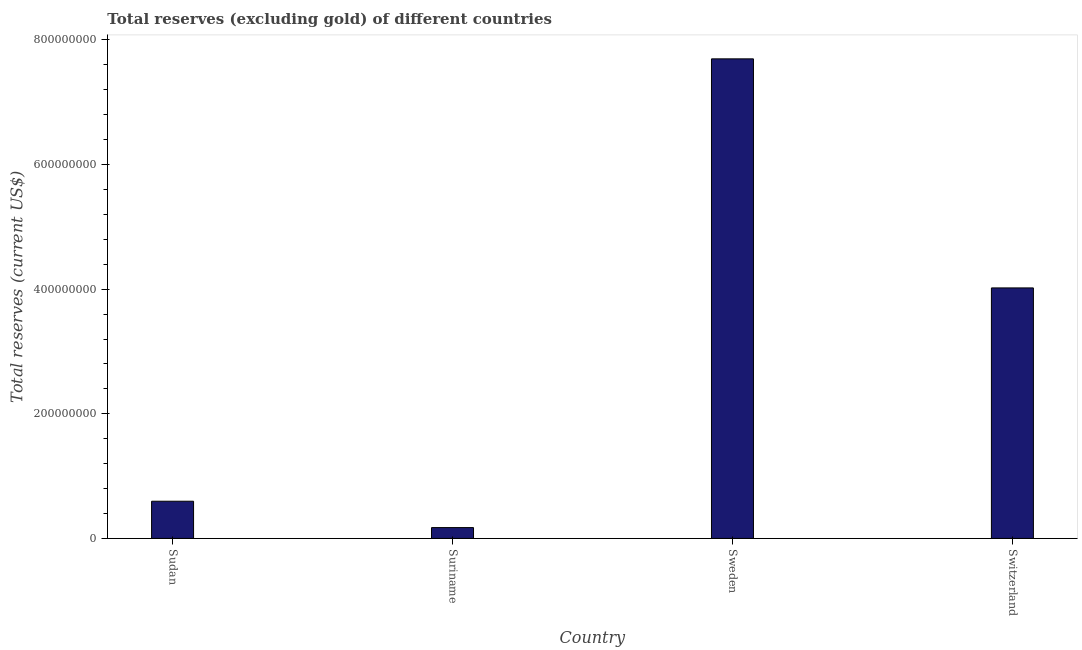Does the graph contain any zero values?
Offer a terse response. No. What is the title of the graph?
Your answer should be very brief. Total reserves (excluding gold) of different countries. What is the label or title of the X-axis?
Your response must be concise. Country. What is the label or title of the Y-axis?
Make the answer very short. Total reserves (current US$). What is the total reserves (excluding gold) in Switzerland?
Ensure brevity in your answer.  4.02e+08. Across all countries, what is the maximum total reserves (excluding gold)?
Ensure brevity in your answer.  7.70e+08. Across all countries, what is the minimum total reserves (excluding gold)?
Offer a terse response. 1.74e+07. In which country was the total reserves (excluding gold) minimum?
Ensure brevity in your answer.  Suriname. What is the sum of the total reserves (excluding gold)?
Your response must be concise. 1.25e+09. What is the difference between the total reserves (excluding gold) in Sudan and Suriname?
Make the answer very short. 4.23e+07. What is the average total reserves (excluding gold) per country?
Offer a terse response. 3.12e+08. What is the median total reserves (excluding gold)?
Provide a short and direct response. 2.31e+08. In how many countries, is the total reserves (excluding gold) greater than 760000000 US$?
Offer a terse response. 1. What is the ratio of the total reserves (excluding gold) in Sudan to that in Sweden?
Keep it short and to the point. 0.08. Is the difference between the total reserves (excluding gold) in Suriname and Sweden greater than the difference between any two countries?
Give a very brief answer. Yes. What is the difference between the highest and the second highest total reserves (excluding gold)?
Give a very brief answer. 3.68e+08. Is the sum of the total reserves (excluding gold) in Sudan and Switzerland greater than the maximum total reserves (excluding gold) across all countries?
Give a very brief answer. No. What is the difference between the highest and the lowest total reserves (excluding gold)?
Make the answer very short. 7.52e+08. In how many countries, is the total reserves (excluding gold) greater than the average total reserves (excluding gold) taken over all countries?
Ensure brevity in your answer.  2. How many bars are there?
Make the answer very short. 4. How many countries are there in the graph?
Provide a short and direct response. 4. What is the difference between two consecutive major ticks on the Y-axis?
Your answer should be very brief. 2.00e+08. What is the Total reserves (current US$) in Sudan?
Give a very brief answer. 5.97e+07. What is the Total reserves (current US$) of Suriname?
Offer a terse response. 1.74e+07. What is the Total reserves (current US$) in Sweden?
Offer a terse response. 7.70e+08. What is the Total reserves (current US$) in Switzerland?
Keep it short and to the point. 4.02e+08. What is the difference between the Total reserves (current US$) in Sudan and Suriname?
Make the answer very short. 4.23e+07. What is the difference between the Total reserves (current US$) in Sudan and Sweden?
Your answer should be compact. -7.10e+08. What is the difference between the Total reserves (current US$) in Sudan and Switzerland?
Give a very brief answer. -3.42e+08. What is the difference between the Total reserves (current US$) in Suriname and Sweden?
Offer a terse response. -7.52e+08. What is the difference between the Total reserves (current US$) in Suriname and Switzerland?
Give a very brief answer. -3.85e+08. What is the difference between the Total reserves (current US$) in Sweden and Switzerland?
Make the answer very short. 3.68e+08. What is the ratio of the Total reserves (current US$) in Sudan to that in Suriname?
Your answer should be compact. 3.43. What is the ratio of the Total reserves (current US$) in Sudan to that in Sweden?
Give a very brief answer. 0.08. What is the ratio of the Total reserves (current US$) in Sudan to that in Switzerland?
Make the answer very short. 0.15. What is the ratio of the Total reserves (current US$) in Suriname to that in Sweden?
Give a very brief answer. 0.02. What is the ratio of the Total reserves (current US$) in Suriname to that in Switzerland?
Keep it short and to the point. 0.04. What is the ratio of the Total reserves (current US$) in Sweden to that in Switzerland?
Give a very brief answer. 1.91. 